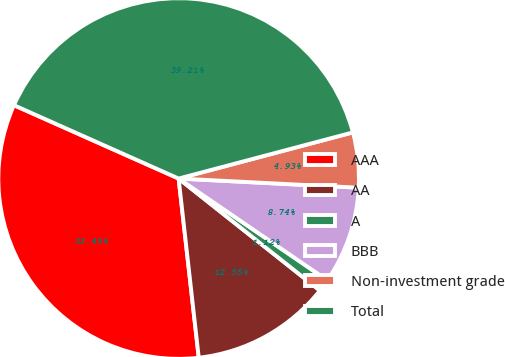Convert chart to OTSL. <chart><loc_0><loc_0><loc_500><loc_500><pie_chart><fcel>AAA<fcel>AA<fcel>A<fcel>BBB<fcel>Non-investment grade<fcel>Total<nl><fcel>33.45%<fcel>12.55%<fcel>1.12%<fcel>8.74%<fcel>4.93%<fcel>39.21%<nl></chart> 